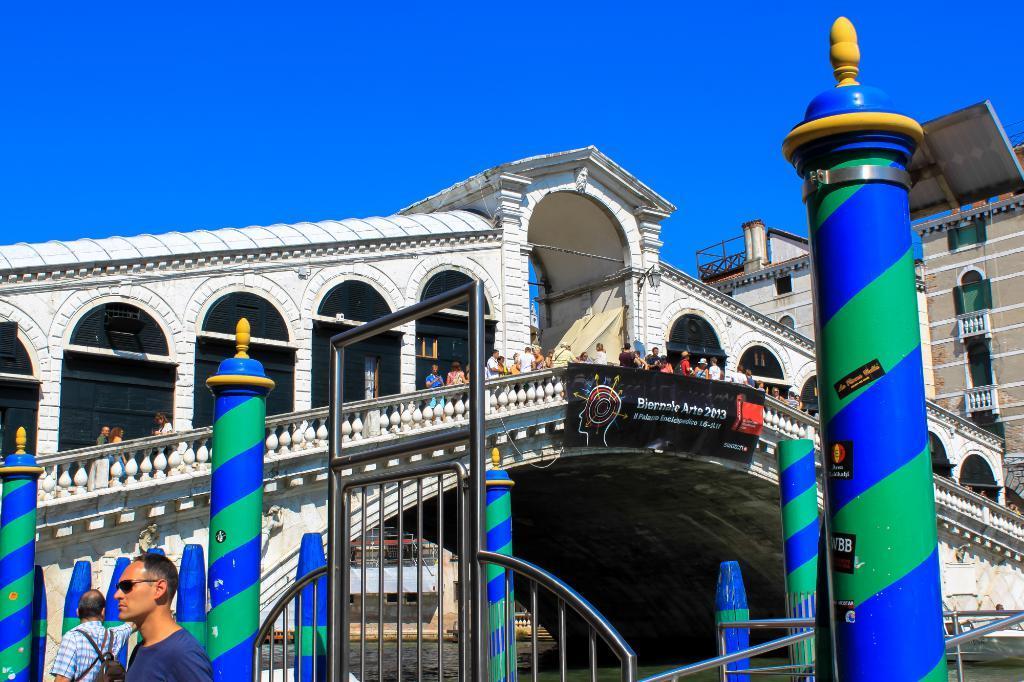Can you describe this image briefly? In this image we can see a bridge. On the bridge we can see a group of persons and a banner attached to the bridge. On the banner there is some text. Behind the bridge there are few buildings. In front of the bridge we can see the water, poles and barriers. In the bottom left there are two persons. At the top we can see the sky. 